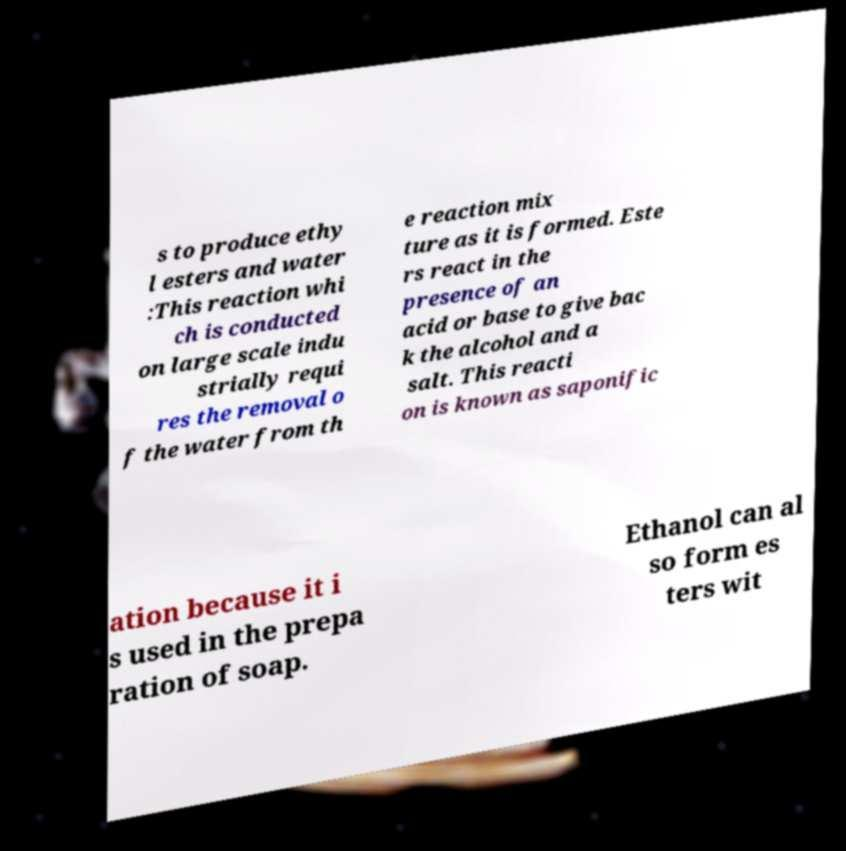Can you read and provide the text displayed in the image?This photo seems to have some interesting text. Can you extract and type it out for me? s to produce ethy l esters and water :This reaction whi ch is conducted on large scale indu strially requi res the removal o f the water from th e reaction mix ture as it is formed. Este rs react in the presence of an acid or base to give bac k the alcohol and a salt. This reacti on is known as saponific ation because it i s used in the prepa ration of soap. Ethanol can al so form es ters wit 